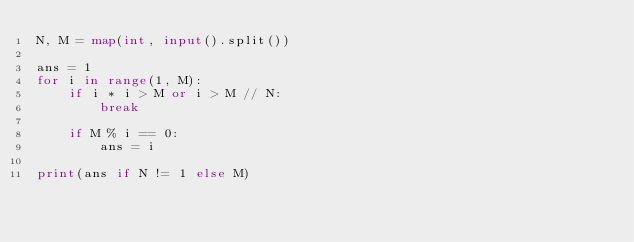<code> <loc_0><loc_0><loc_500><loc_500><_Python_>N, M = map(int, input().split())

ans = 1
for i in range(1, M):
    if i * i > M or i > M // N:
        break
        
    if M % i == 0:
        ans = i
        
print(ans if N != 1 else M)

</code> 